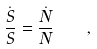Convert formula to latex. <formula><loc_0><loc_0><loc_500><loc_500>\frac { \dot { S } } { S } = \frac { \dot { N } } { N } \quad ,</formula> 